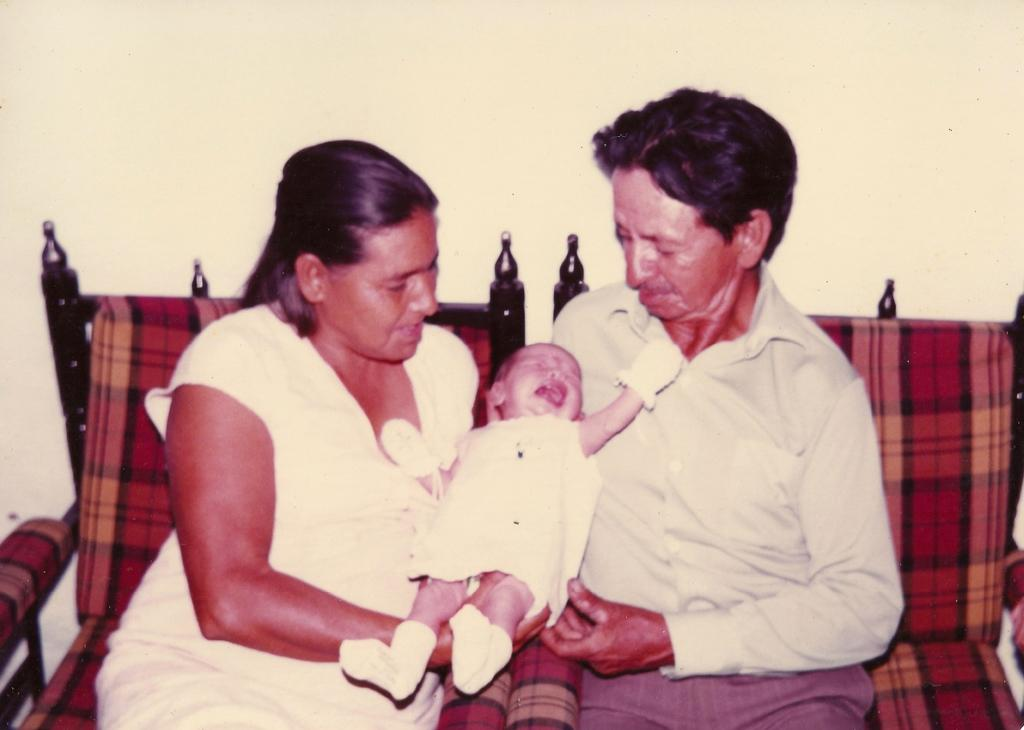Who is present in the image? There is a man and a woman in the image. What are the man and woman doing in the image? The man and woman are sitting on chairs and holding a baby. What is behind the man and woman in the image? There is a wall behind them. What type of coil is being exchanged between the man and woman in the image? There is no coil present in the image, nor is there any exchange taking place between the man and woman. 